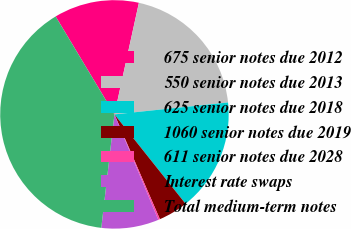<chart> <loc_0><loc_0><loc_500><loc_500><pie_chart><fcel>675 senior notes due 2012<fcel>550 senior notes due 2013<fcel>625 senior notes due 2018<fcel>1060 senior notes due 2019<fcel>611 senior notes due 2028<fcel>Interest rate swaps<fcel>Total medium-term notes<nl><fcel>12.04%<fcel>19.9%<fcel>15.97%<fcel>4.18%<fcel>0.24%<fcel>8.11%<fcel>39.56%<nl></chart> 